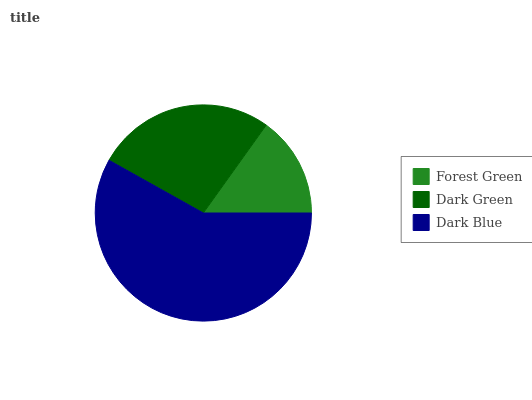Is Forest Green the minimum?
Answer yes or no. Yes. Is Dark Blue the maximum?
Answer yes or no. Yes. Is Dark Green the minimum?
Answer yes or no. No. Is Dark Green the maximum?
Answer yes or no. No. Is Dark Green greater than Forest Green?
Answer yes or no. Yes. Is Forest Green less than Dark Green?
Answer yes or no. Yes. Is Forest Green greater than Dark Green?
Answer yes or no. No. Is Dark Green less than Forest Green?
Answer yes or no. No. Is Dark Green the high median?
Answer yes or no. Yes. Is Dark Green the low median?
Answer yes or no. Yes. Is Forest Green the high median?
Answer yes or no. No. Is Dark Blue the low median?
Answer yes or no. No. 